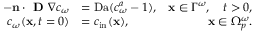Convert formula to latex. <formula><loc_0><loc_0><loc_500><loc_500>\begin{array} { r l r } { - n \cdot D \nabla c _ { \omega } } & { = D a ( c _ { \omega } ^ { a } - 1 ) , } & { x \in \Gamma ^ { \omega } , \quad t > 0 , } \\ { c _ { \omega } ( x , t = 0 ) } & { = c _ { i n } ( x ) , } & { x \in \Omega _ { p } ^ { \omega } . } \end{array}</formula> 